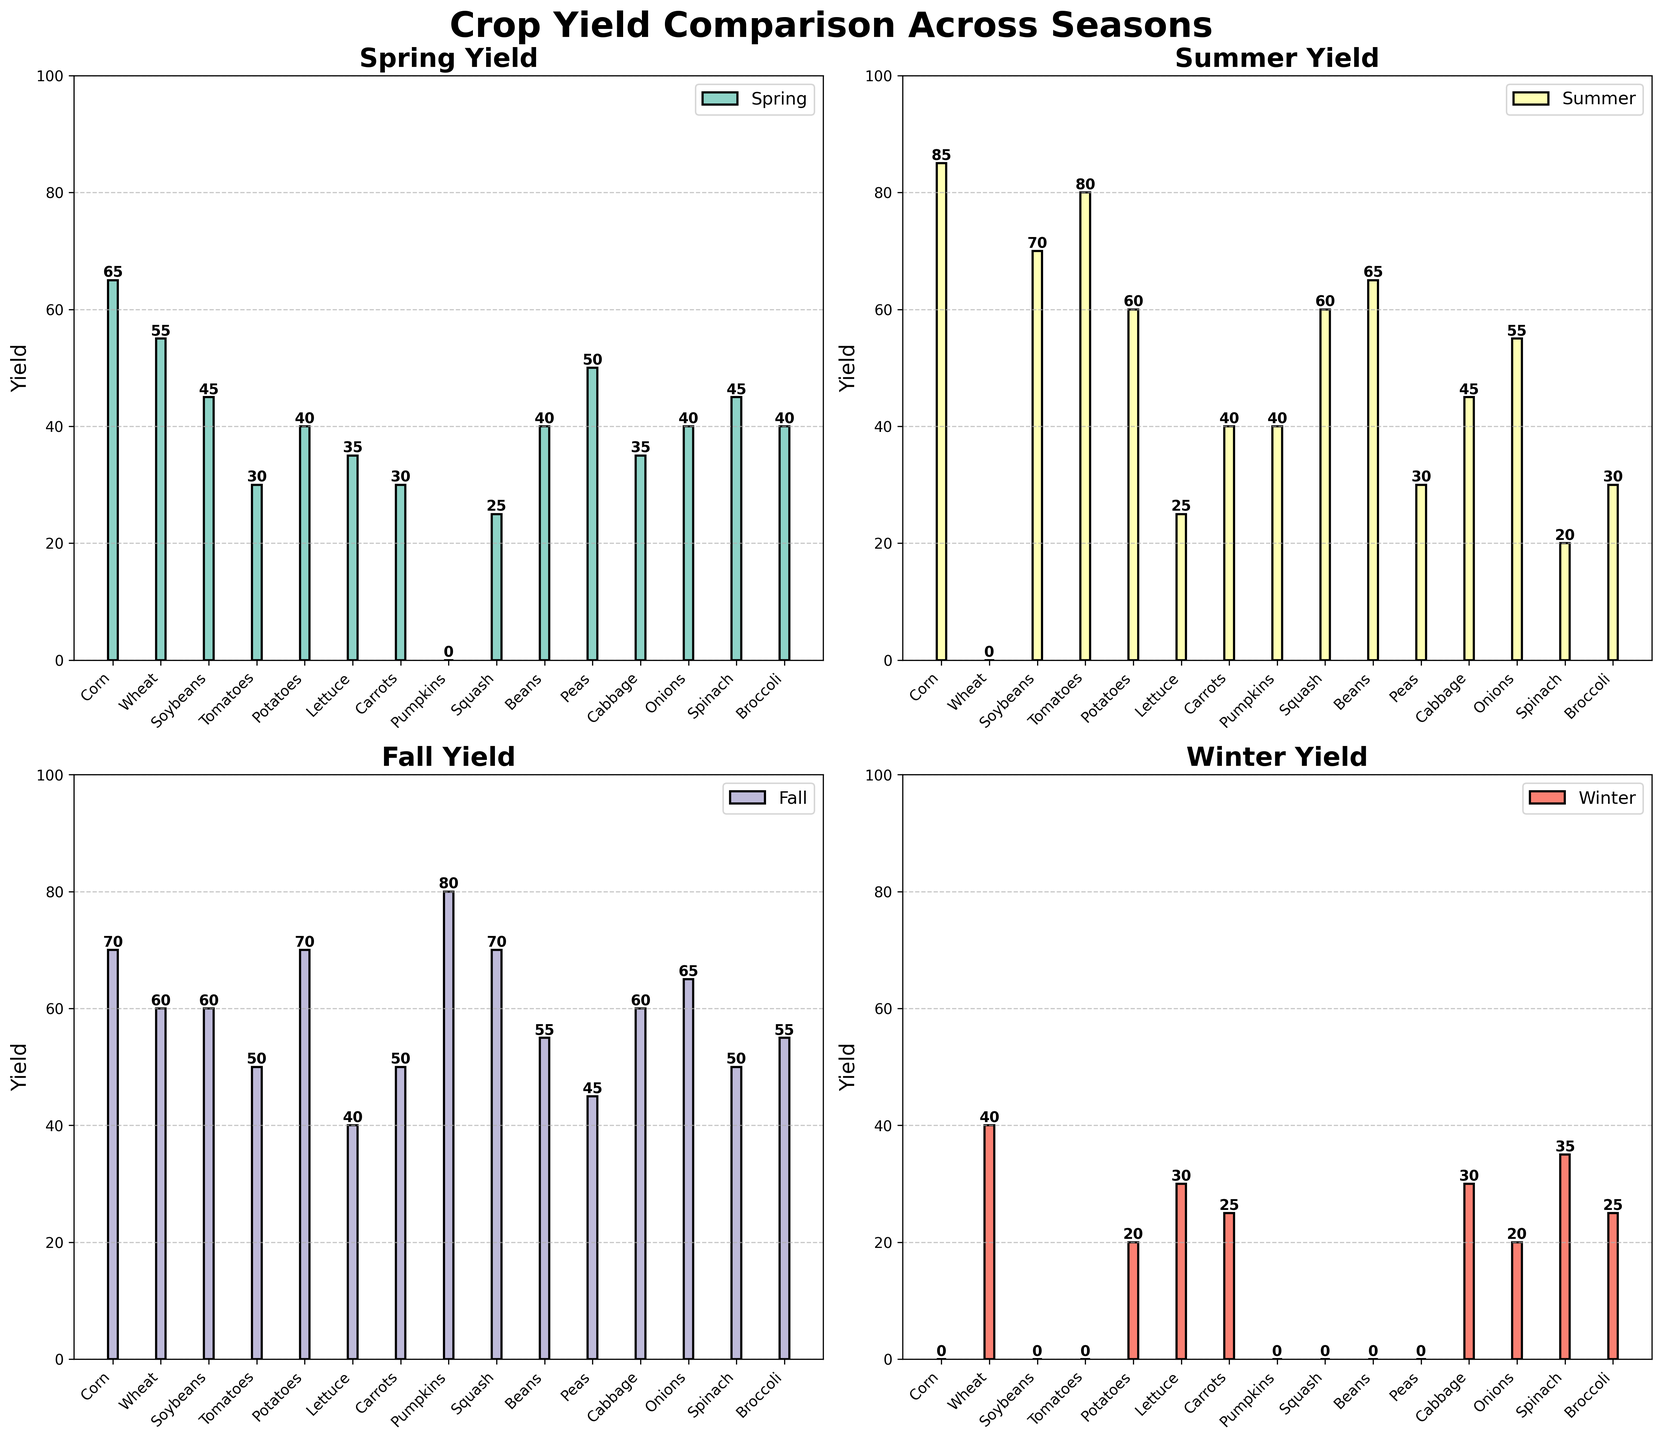Which season has the highest yield for Corn? To determine the highest yield for Corn, look across the Corn bars in each subplot. Spring has 65, Summer has 85, Fall has 70, and Winter has 0. The highest yield occurs in Summer.
Answer: Summer Compare the yield of Potatoes in Fall and Winter. Which one is greater and by how much? Locate the Potatoes bars in the Fall and Winter subplots. Fall yields 70, and Winter yields 20. Subtracting Winter’s yield from Fall’s yield gives 70 - 20 = 50.
Answer: Fall by 50 What is the total yield for Tomatoes across all seasons? Check the values for Tomatoes in each subplot: Spring - 30, Summer - 80, Fall - 50, Winter - 0. Adding them, 30 + 80 + 50 + 0 = 160.
Answer: 160 Which crop has the lowest yield in Summer? Identify all the yields in the Summer subplot. The lowest value is 0 for Wheat.
Answer: Wheat How does the yield of Beans in Summer compare to Peas in Spring? The yield of Beans in Summer is 65, and the yield of Peas in Spring is 50. Comparing these, Beans in Summer has a higher yield.
Answer: Beans in Summer What is the average yield of all crops in Winter? Calculate the total yield in Winter by summing up all yields and dividing by the number of crops. Yields are 0, 40, 0, 0, 20, 30, 25, 0, 0, 0, 0, 30, 20, 35, 25. The total is 225, and there are 15 crops; thus, the average is 225/15 = 15.
Answer: 15 Which crop has the most consistent yield across all seasons? Consistency means minimal variation. Check all subplots for crops with similar heights. Corn and Onions vary greatly, but Carrots (30, 40, 50, 25) have yields close to each other across seasons, indicating consistent yields.
Answer: Carrots In which season are the overall crop yields the highest? Summarize all yields for each season. Spring: 540, Summer: 630, Fall: 725, Winter: 225. The highest is in Fall.
Answer: Fall Which crop has a higher yield in Spring: Broccoli or Cabbage? Compare Broccoli and Cabbage in the Spring subplot. Broccoli yields 40, while Cabbage yields 35. Hence, Broccoli has a higher yield.
Answer: Broccoli 